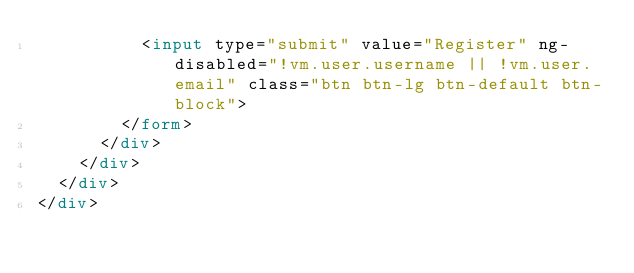<code> <loc_0><loc_0><loc_500><loc_500><_HTML_>          <input type="submit" value="Register" ng-disabled="!vm.user.username || !vm.user.email" class="btn btn-lg btn-default btn-block">
        </form>
      </div>
    </div>
  </div>
</div>
</code> 